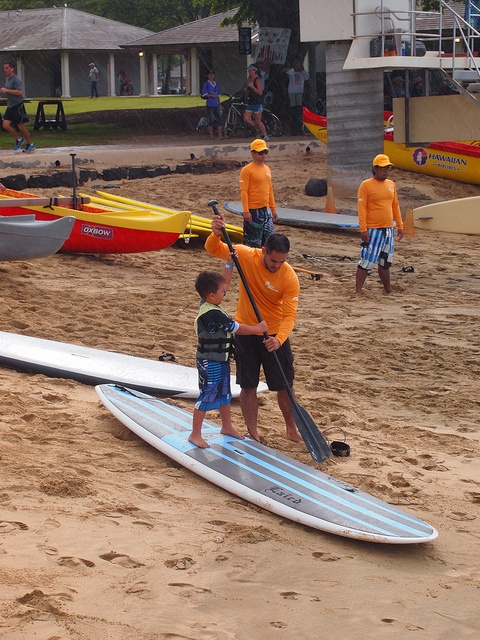Describe the objects in this image and their specific colors. I can see surfboard in black, darkgray, lightgray, and lightblue tones, people in black, brown, maroon, and red tones, boat in black, brown, orange, and maroon tones, boat in black, gray, olive, and maroon tones, and surfboard in black, white, gray, and darkgray tones in this image. 